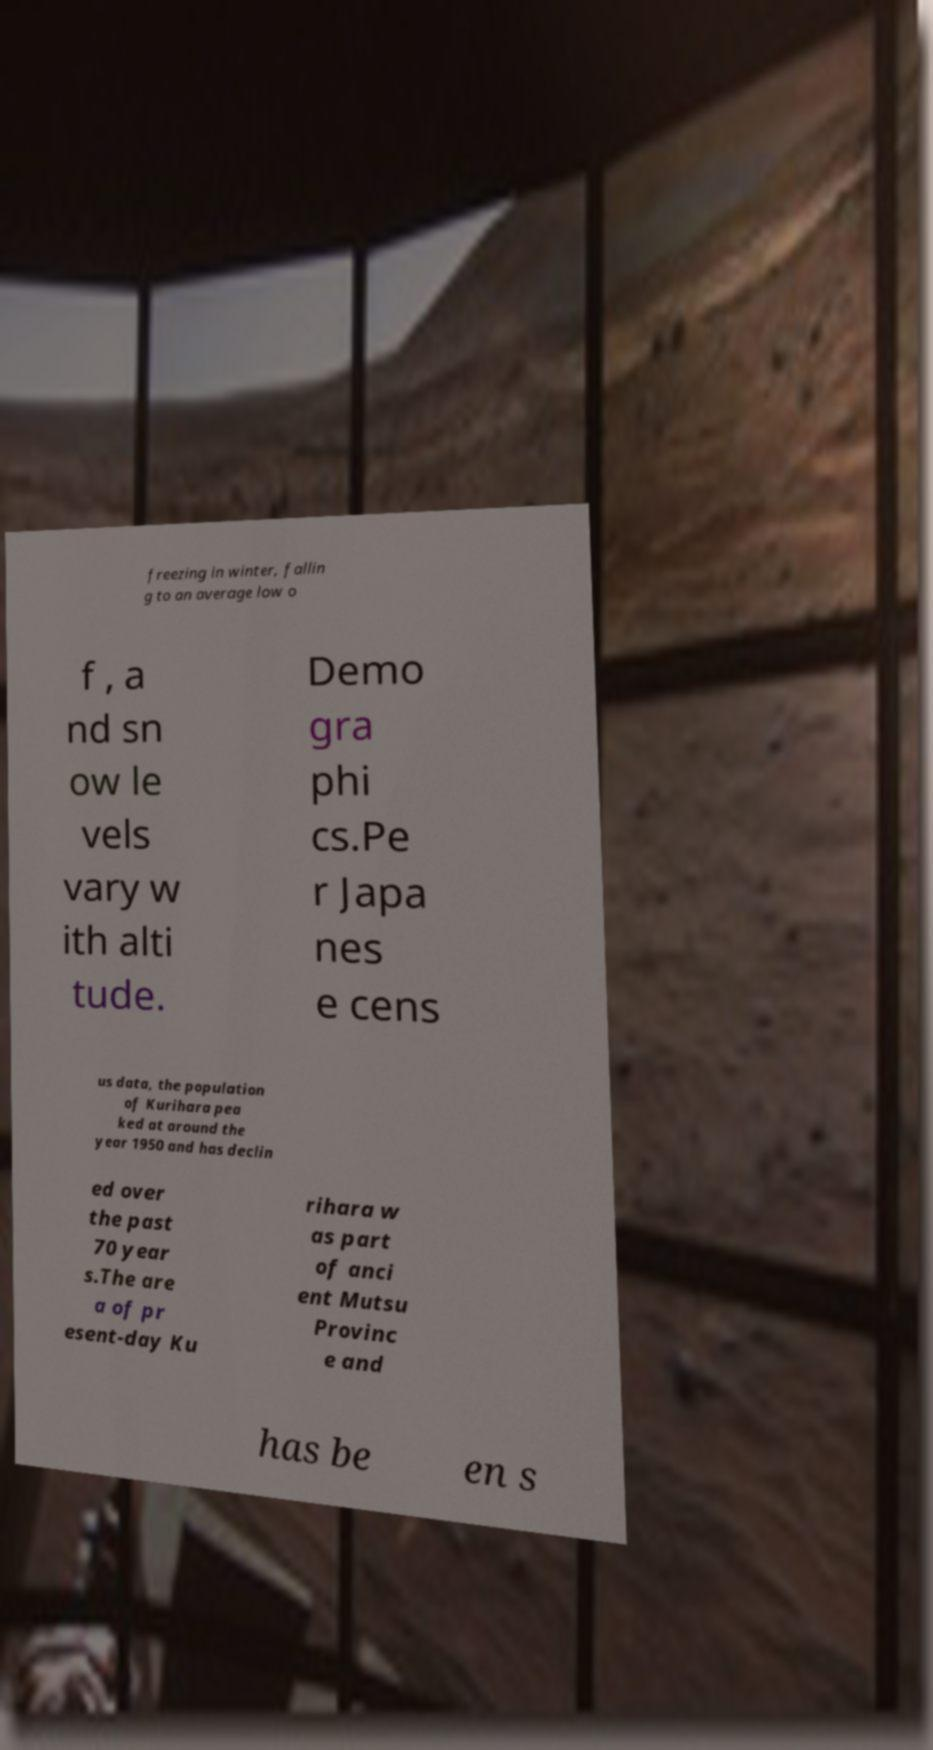I need the written content from this picture converted into text. Can you do that? freezing in winter, fallin g to an average low o f , a nd sn ow le vels vary w ith alti tude. Demo gra phi cs.Pe r Japa nes e cens us data, the population of Kurihara pea ked at around the year 1950 and has declin ed over the past 70 year s.The are a of pr esent-day Ku rihara w as part of anci ent Mutsu Provinc e and has be en s 